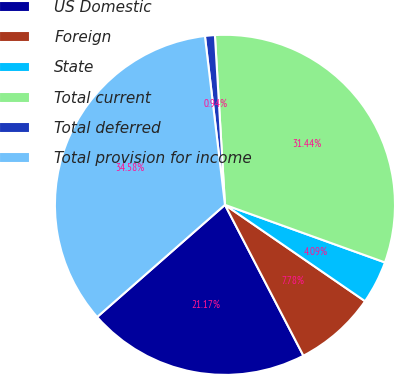Convert chart. <chart><loc_0><loc_0><loc_500><loc_500><pie_chart><fcel>US Domestic<fcel>Foreign<fcel>State<fcel>Total current<fcel>Total deferred<fcel>Total provision for income<nl><fcel>21.17%<fcel>7.78%<fcel>4.09%<fcel>31.44%<fcel>0.94%<fcel>34.58%<nl></chart> 